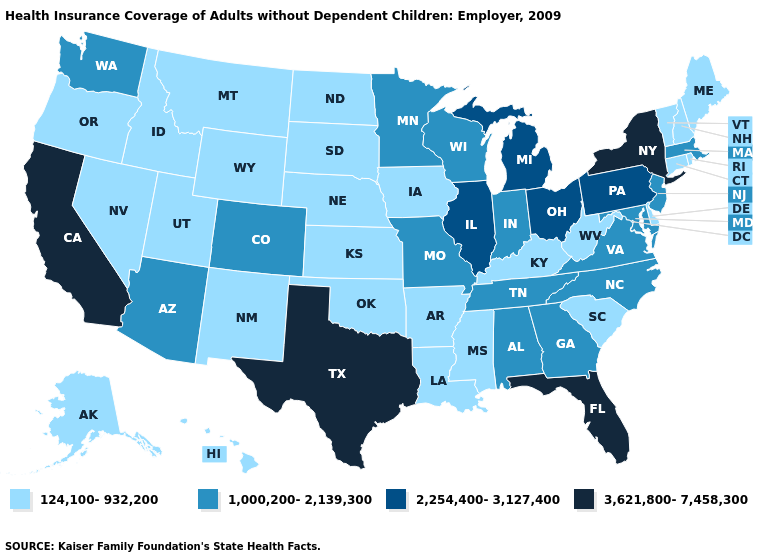Does the first symbol in the legend represent the smallest category?
Give a very brief answer. Yes. Does Louisiana have the lowest value in the USA?
Write a very short answer. Yes. What is the lowest value in the MidWest?
Keep it brief. 124,100-932,200. What is the value of Colorado?
Short answer required. 1,000,200-2,139,300. What is the value of Washington?
Give a very brief answer. 1,000,200-2,139,300. What is the value of Louisiana?
Short answer required. 124,100-932,200. Does the first symbol in the legend represent the smallest category?
Quick response, please. Yes. What is the value of Virginia?
Short answer required. 1,000,200-2,139,300. Does the first symbol in the legend represent the smallest category?
Short answer required. Yes. Does the map have missing data?
Concise answer only. No. Name the states that have a value in the range 1,000,200-2,139,300?
Quick response, please. Alabama, Arizona, Colorado, Georgia, Indiana, Maryland, Massachusetts, Minnesota, Missouri, New Jersey, North Carolina, Tennessee, Virginia, Washington, Wisconsin. What is the value of Texas?
Quick response, please. 3,621,800-7,458,300. What is the value of Vermont?
Be succinct. 124,100-932,200. Name the states that have a value in the range 2,254,400-3,127,400?
Give a very brief answer. Illinois, Michigan, Ohio, Pennsylvania. Does Florida have the highest value in the USA?
Concise answer only. Yes. 